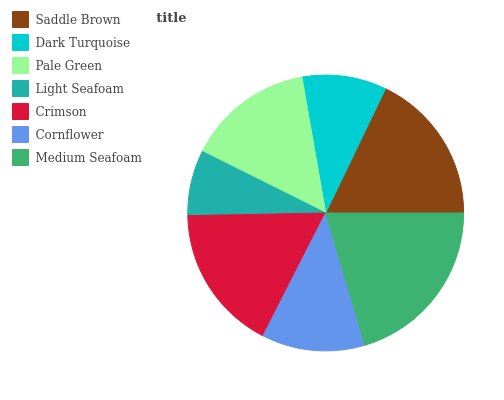Is Light Seafoam the minimum?
Answer yes or no. Yes. Is Medium Seafoam the maximum?
Answer yes or no. Yes. Is Dark Turquoise the minimum?
Answer yes or no. No. Is Dark Turquoise the maximum?
Answer yes or no. No. Is Saddle Brown greater than Dark Turquoise?
Answer yes or no. Yes. Is Dark Turquoise less than Saddle Brown?
Answer yes or no. Yes. Is Dark Turquoise greater than Saddle Brown?
Answer yes or no. No. Is Saddle Brown less than Dark Turquoise?
Answer yes or no. No. Is Pale Green the high median?
Answer yes or no. Yes. Is Pale Green the low median?
Answer yes or no. Yes. Is Crimson the high median?
Answer yes or no. No. Is Dark Turquoise the low median?
Answer yes or no. No. 